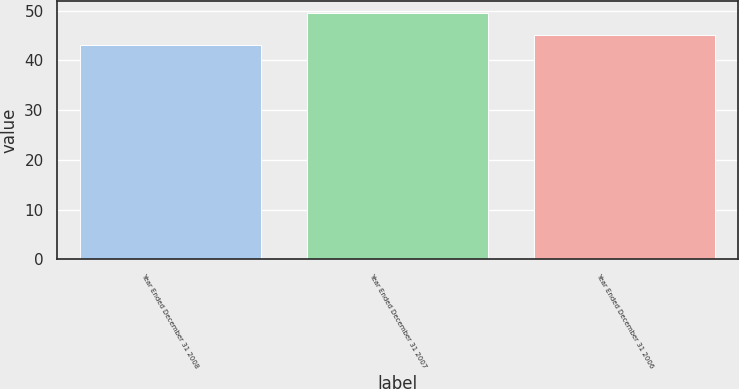Convert chart to OTSL. <chart><loc_0><loc_0><loc_500><loc_500><bar_chart><fcel>Year Ended December 31 2008<fcel>Year Ended December 31 2007<fcel>Year Ended December 31 2006<nl><fcel>43.1<fcel>49.5<fcel>45<nl></chart> 